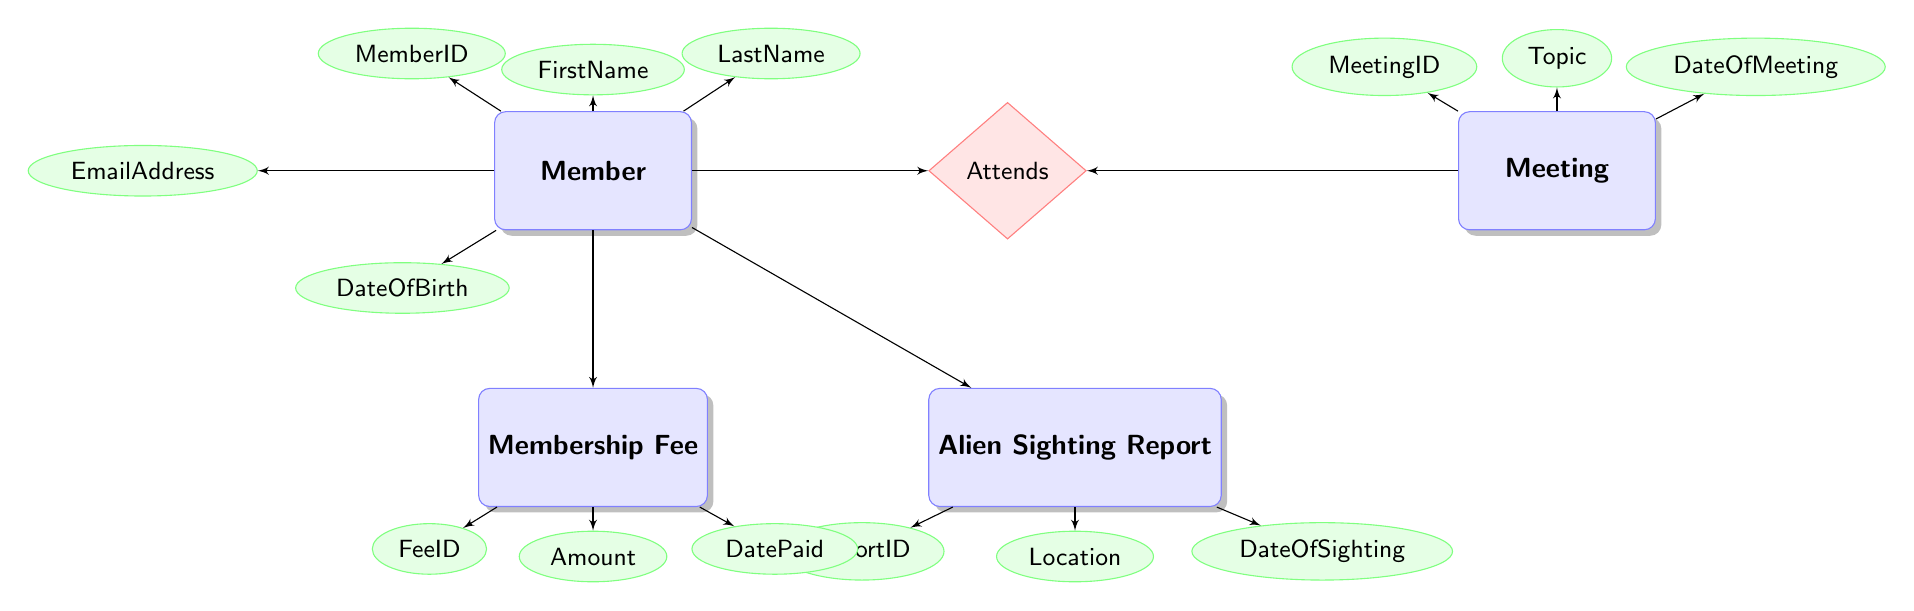What is the primary key of the Member entity? The primary key of the Member entity is indicated in the diagram as “MemberID”, which is essential for identifying unique members within the database.
Answer: MemberID How many attributes does the Alien Sighting Report entity have? The Alien Sighting Report entity is shown to have three attributes, which include ReportID, Location, and DateOfSighting. Thus, by counting these, we find the total.
Answer: 3 What does the Attendance relationship represent? The Attendance relationship connects the Member and Meeting entities, indicating which members attend which meetings, reflecting active participation within the club.
Answer: Members attending meetings Which entity references the MemberID as a foreign key? The entities that reference MemberID as a foreign key include Alien Sighting Report, Attendance, and Membership Fee, showing a direct relationship to the Member.
Answer: Alien Sighting Report, Attendance, Membership Fee What is the total number of entities in the diagram? The diagram contains five entities: Member, Alien Sighting Report, Meeting, Attendance, and Membership Fee, and thus counting these gives the total number of entities.
Answer: 5 What is the primary key of the Membership Fee entity? The primary key of the Membership Fee entity is identified as “FeeID” in the diagram, which uniquely distinguishes each fee entry for the members.
Answer: FeeID How many foreign keys are present in the Attendance entity? The Attendance entity has two foreign keys: MemberID and MeetingID, which illustrate its connections to the Member and Meeting entities respectively.
Answer: 2 What are the attributes of the Meeting entity? The attributes of the Meeting entity mentioned in the diagram are MeetingID, Topic, and DateOfMeeting, reflecting essential details related to each meeting.
Answer: MeetingID, Topic, DateOfMeeting Which entity has a relationship with both Member and Meeting? The Attendance entity has a relationship with both the Member and Meeting entities, as it links members to the meetings they attend as indicated by its connections.
Answer: Attendance 